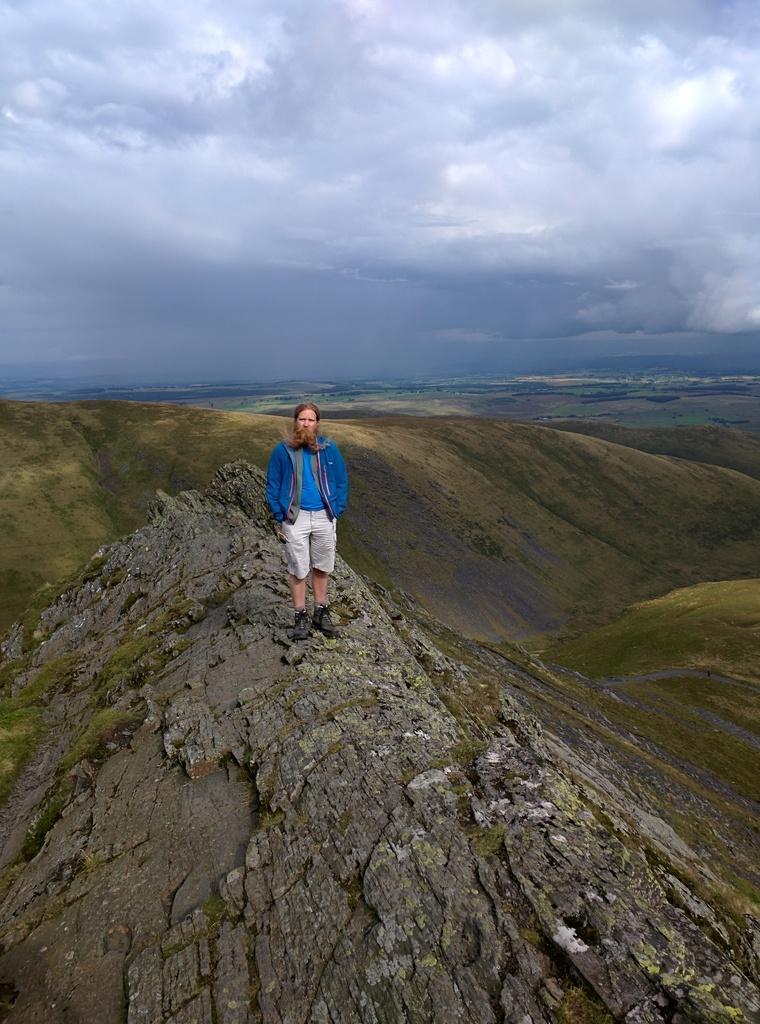In one or two sentences, can you explain what this image depicts? In this image there is a man standing on a mountain, in the background there are mountains and the sky. 